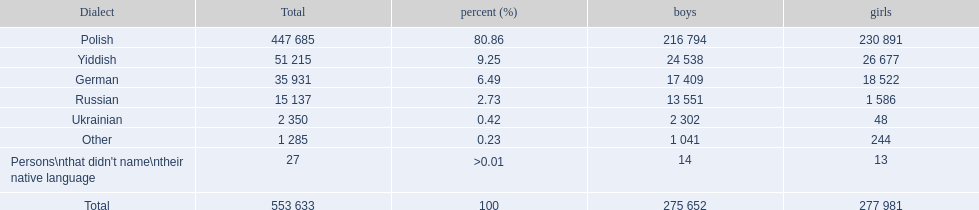What was the least spoken language Ukrainian. What was the most spoken? Polish. 